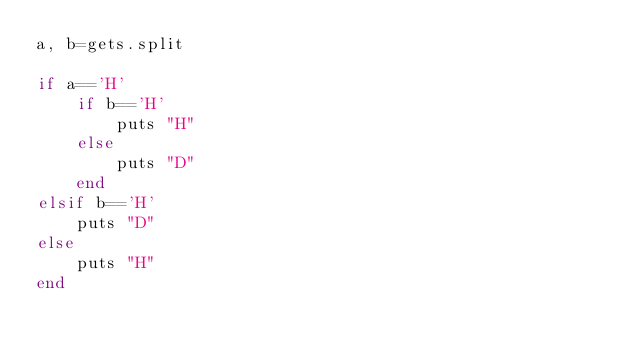<code> <loc_0><loc_0><loc_500><loc_500><_Ruby_>a, b=gets.split

if a=='H'
    if b=='H'
        puts "H"
    else
        puts "D"
    end
elsif b=='H'
    puts "D"
else 
    puts "H"
end</code> 